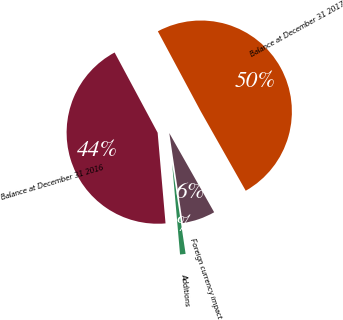Convert chart. <chart><loc_0><loc_0><loc_500><loc_500><pie_chart><fcel>Balance at December 31 2016<fcel>Additions<fcel>Foreign currency impact<fcel>Balance at December 31 2017<nl><fcel>43.55%<fcel>0.98%<fcel>5.84%<fcel>49.63%<nl></chart> 